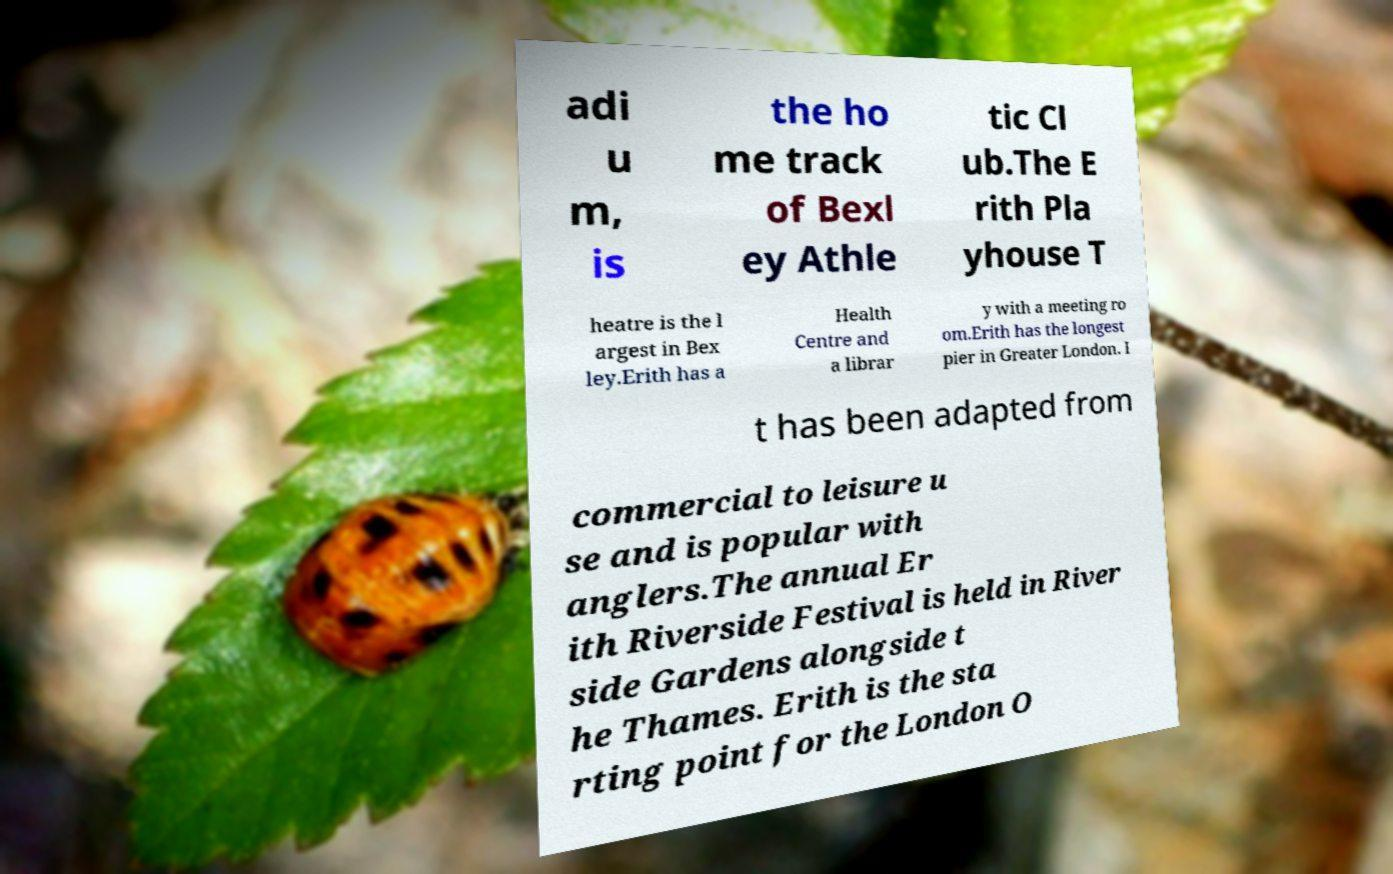Please read and relay the text visible in this image. What does it say? adi u m, is the ho me track of Bexl ey Athle tic Cl ub.The E rith Pla yhouse T heatre is the l argest in Bex ley.Erith has a Health Centre and a librar y with a meeting ro om.Erith has the longest pier in Greater London. I t has been adapted from commercial to leisure u se and is popular with anglers.The annual Er ith Riverside Festival is held in River side Gardens alongside t he Thames. Erith is the sta rting point for the London O 